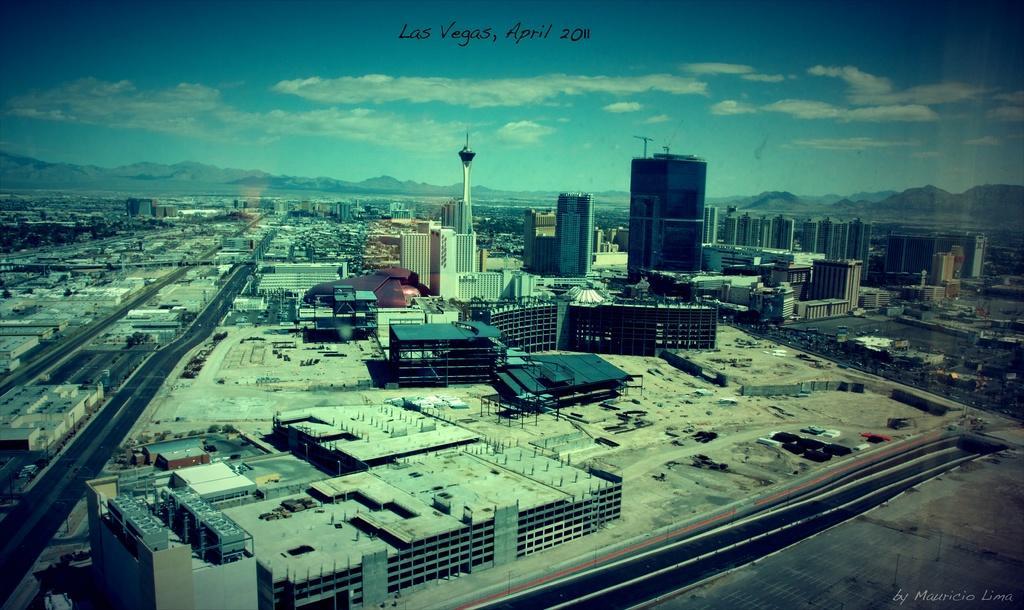Could you give a brief overview of what you see in this image? In this image I can see a top view of a city. I can see roads, buildings, a tower, mountains. At the top of the image I can see the sky and some text in the center at the top. 